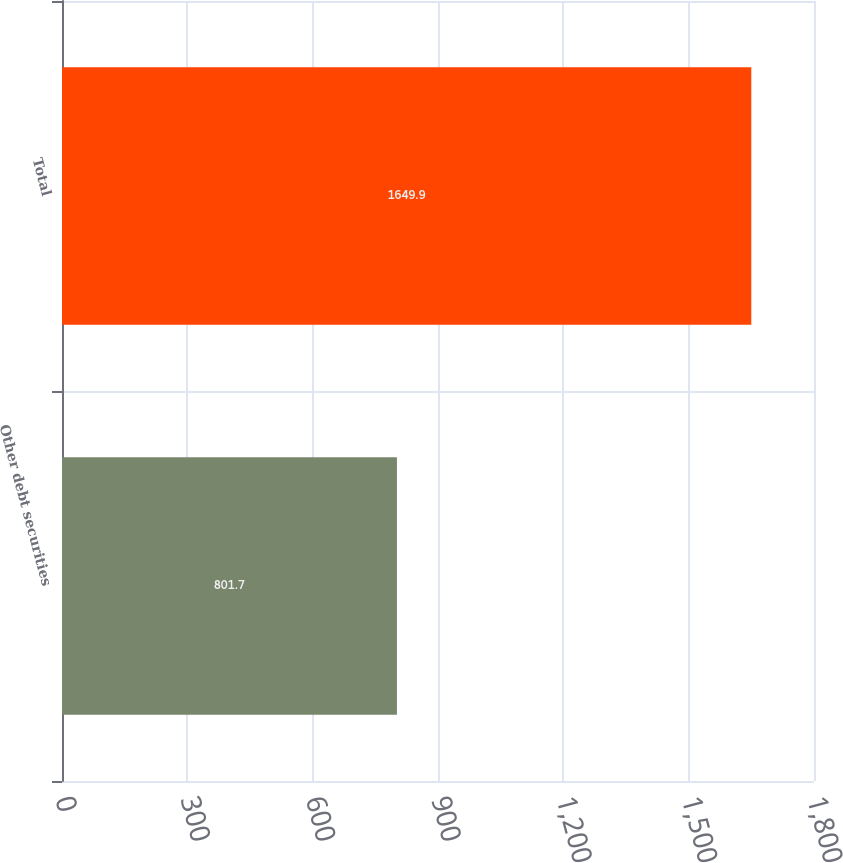<chart> <loc_0><loc_0><loc_500><loc_500><bar_chart><fcel>Other debt securities<fcel>Total<nl><fcel>801.7<fcel>1649.9<nl></chart> 